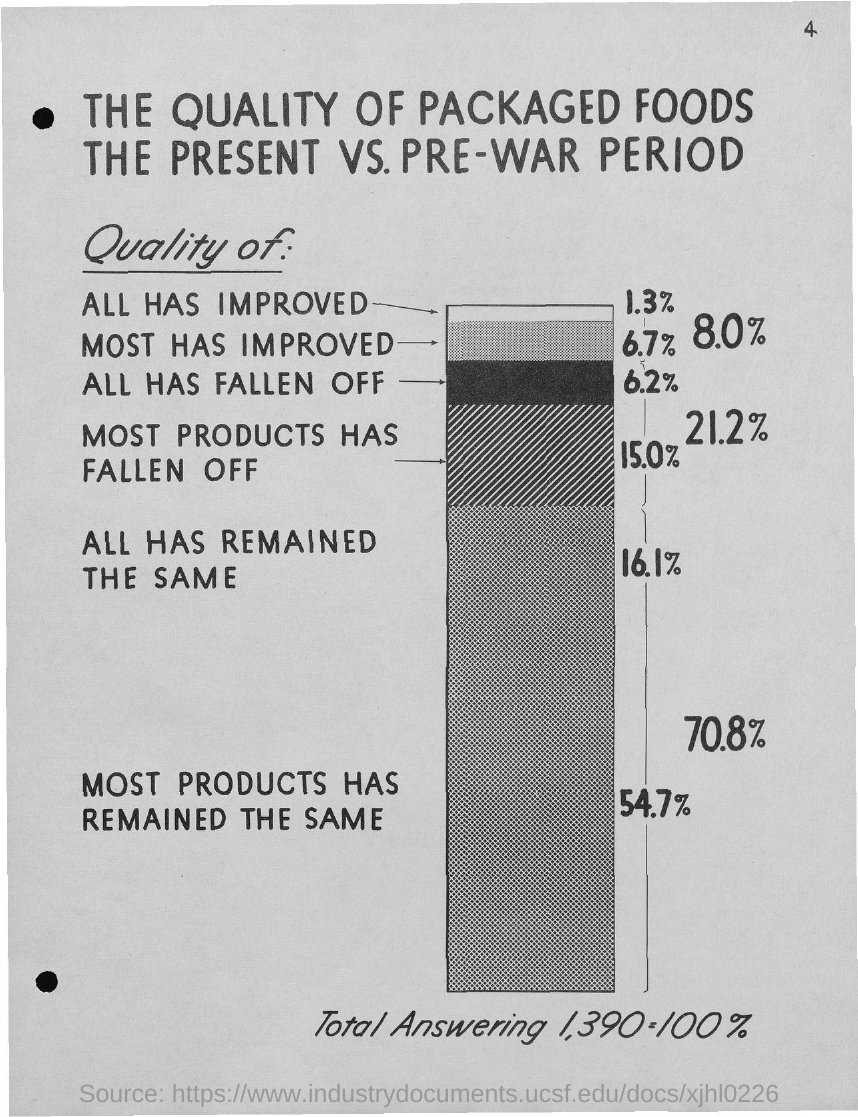What is the page number?
Provide a short and direct response. 4. What is the first title in the document?
Provide a succinct answer. The quality of packaged foods. 